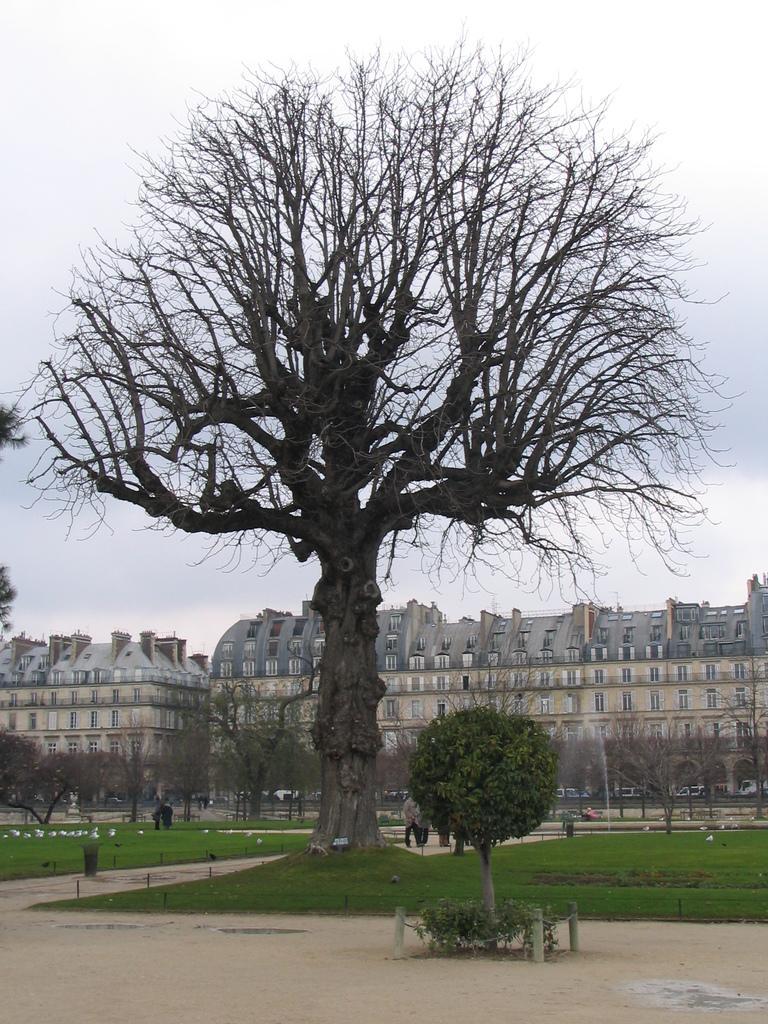Could you give a brief overview of what you see in this image? In this image I can see trees in green color. Background I can see few persons walking, dried trees, building in cream color and sky in white color. 